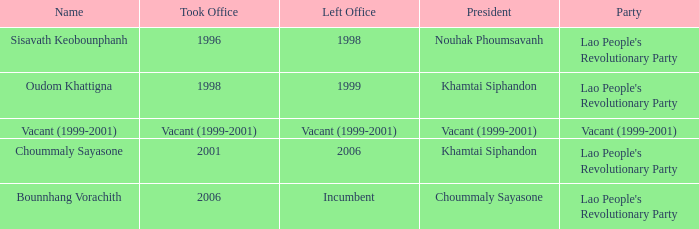When the took office year is 2006, what is the left office year? Incumbent. 